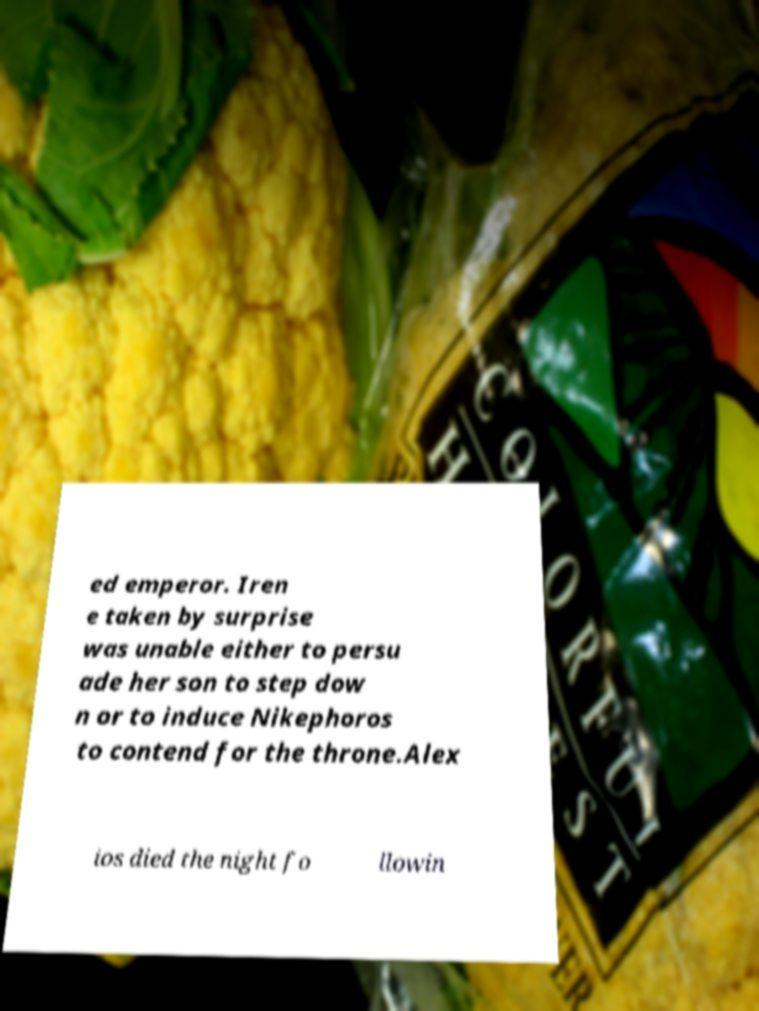Can you accurately transcribe the text from the provided image for me? ed emperor. Iren e taken by surprise was unable either to persu ade her son to step dow n or to induce Nikephoros to contend for the throne.Alex ios died the night fo llowin 